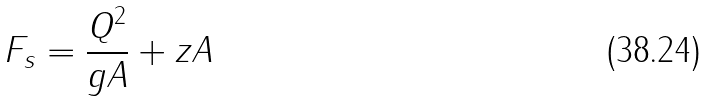Convert formula to latex. <formula><loc_0><loc_0><loc_500><loc_500>F _ { s } = \frac { Q ^ { 2 } } { g A } + z A</formula> 